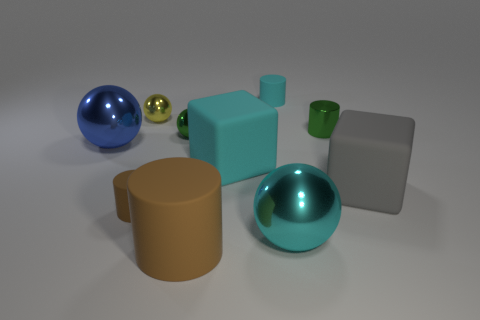Is the gray rubber block the same size as the yellow thing?
Give a very brief answer. No. What number of objects are gray blocks or large gray cubes to the right of the cyan matte block?
Your answer should be compact. 1. What number of things are either big cyan rubber blocks that are on the left side of the large gray matte object or shiny objects behind the tiny green sphere?
Keep it short and to the point. 3. There is a large blue sphere; are there any green metallic objects in front of it?
Your answer should be very brief. No. There is a rubber thing that is behind the cylinder on the right side of the large metal sphere right of the big cylinder; what color is it?
Provide a short and direct response. Cyan. Do the tiny brown matte object and the small yellow object have the same shape?
Make the answer very short. No. What is the color of the tiny sphere that is made of the same material as the tiny yellow thing?
Your answer should be compact. Green. How many objects are either small yellow metallic objects behind the big brown object or tiny metallic balls?
Your answer should be compact. 2. How big is the shiny ball that is to the left of the small yellow metallic object?
Make the answer very short. Large. Is the size of the blue shiny thing the same as the thing that is on the right side of the small green metallic cylinder?
Your answer should be compact. Yes. 